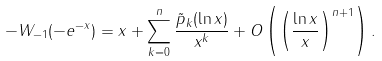<formula> <loc_0><loc_0><loc_500><loc_500>- W _ { - 1 } ( - e ^ { - x } ) = x + \sum ^ { n } _ { k = 0 } \frac { \tilde { p } _ { k } ( \ln x ) } { x ^ { k } } + O \left ( \left ( \frac { \ln x } { x } \right ) ^ { n + 1 } \right ) .</formula> 